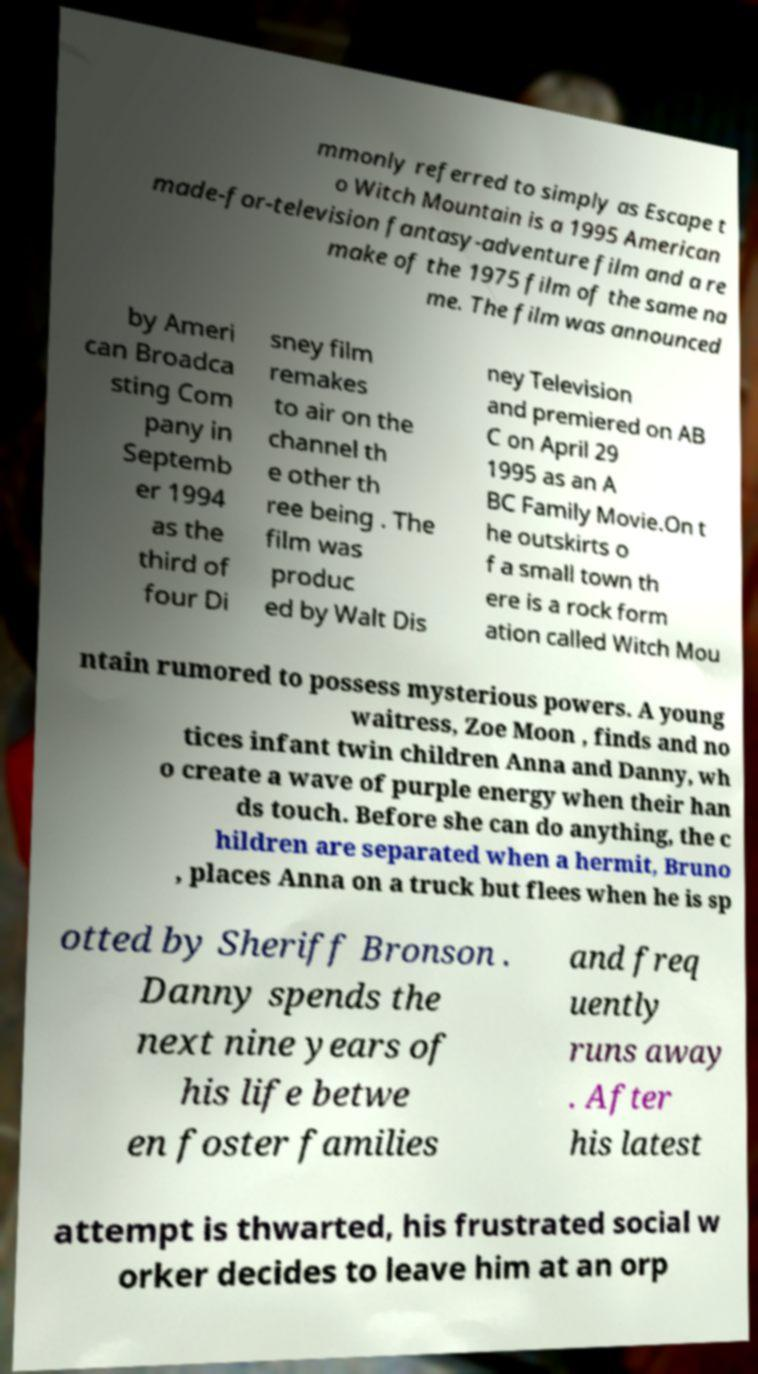Could you extract and type out the text from this image? mmonly referred to simply as Escape t o Witch Mountain is a 1995 American made-for-television fantasy-adventure film and a re make of the 1975 film of the same na me. The film was announced by Ameri can Broadca sting Com pany in Septemb er 1994 as the third of four Di sney film remakes to air on the channel th e other th ree being . The film was produc ed by Walt Dis ney Television and premiered on AB C on April 29 1995 as an A BC Family Movie.On t he outskirts o f a small town th ere is a rock form ation called Witch Mou ntain rumored to possess mysterious powers. A young waitress, Zoe Moon , finds and no tices infant twin children Anna and Danny, wh o create a wave of purple energy when their han ds touch. Before she can do anything, the c hildren are separated when a hermit, Bruno , places Anna on a truck but flees when he is sp otted by Sheriff Bronson . Danny spends the next nine years of his life betwe en foster families and freq uently runs away . After his latest attempt is thwarted, his frustrated social w orker decides to leave him at an orp 